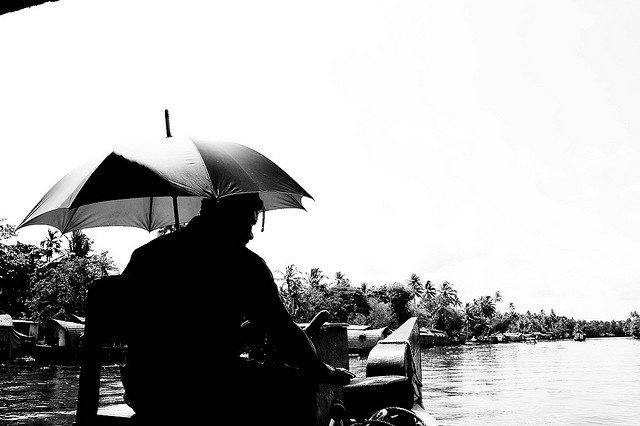Describe the objects in this image and their specific colors. I can see people in black, gray, white, and darkgray tones, umbrella in black, white, gray, and darkgray tones, boat in black, white, gray, and darkgray tones, and boat in black, darkgray, lightgray, and gray tones in this image. 